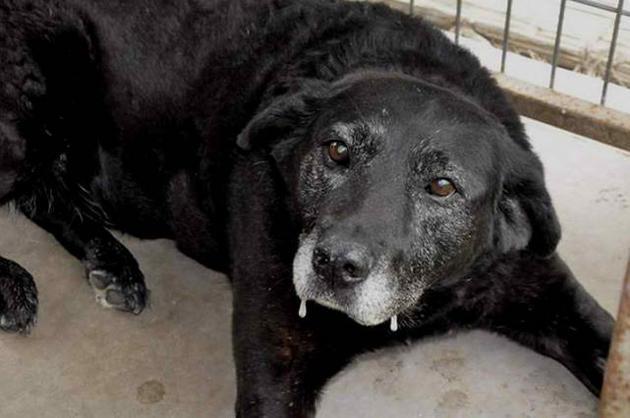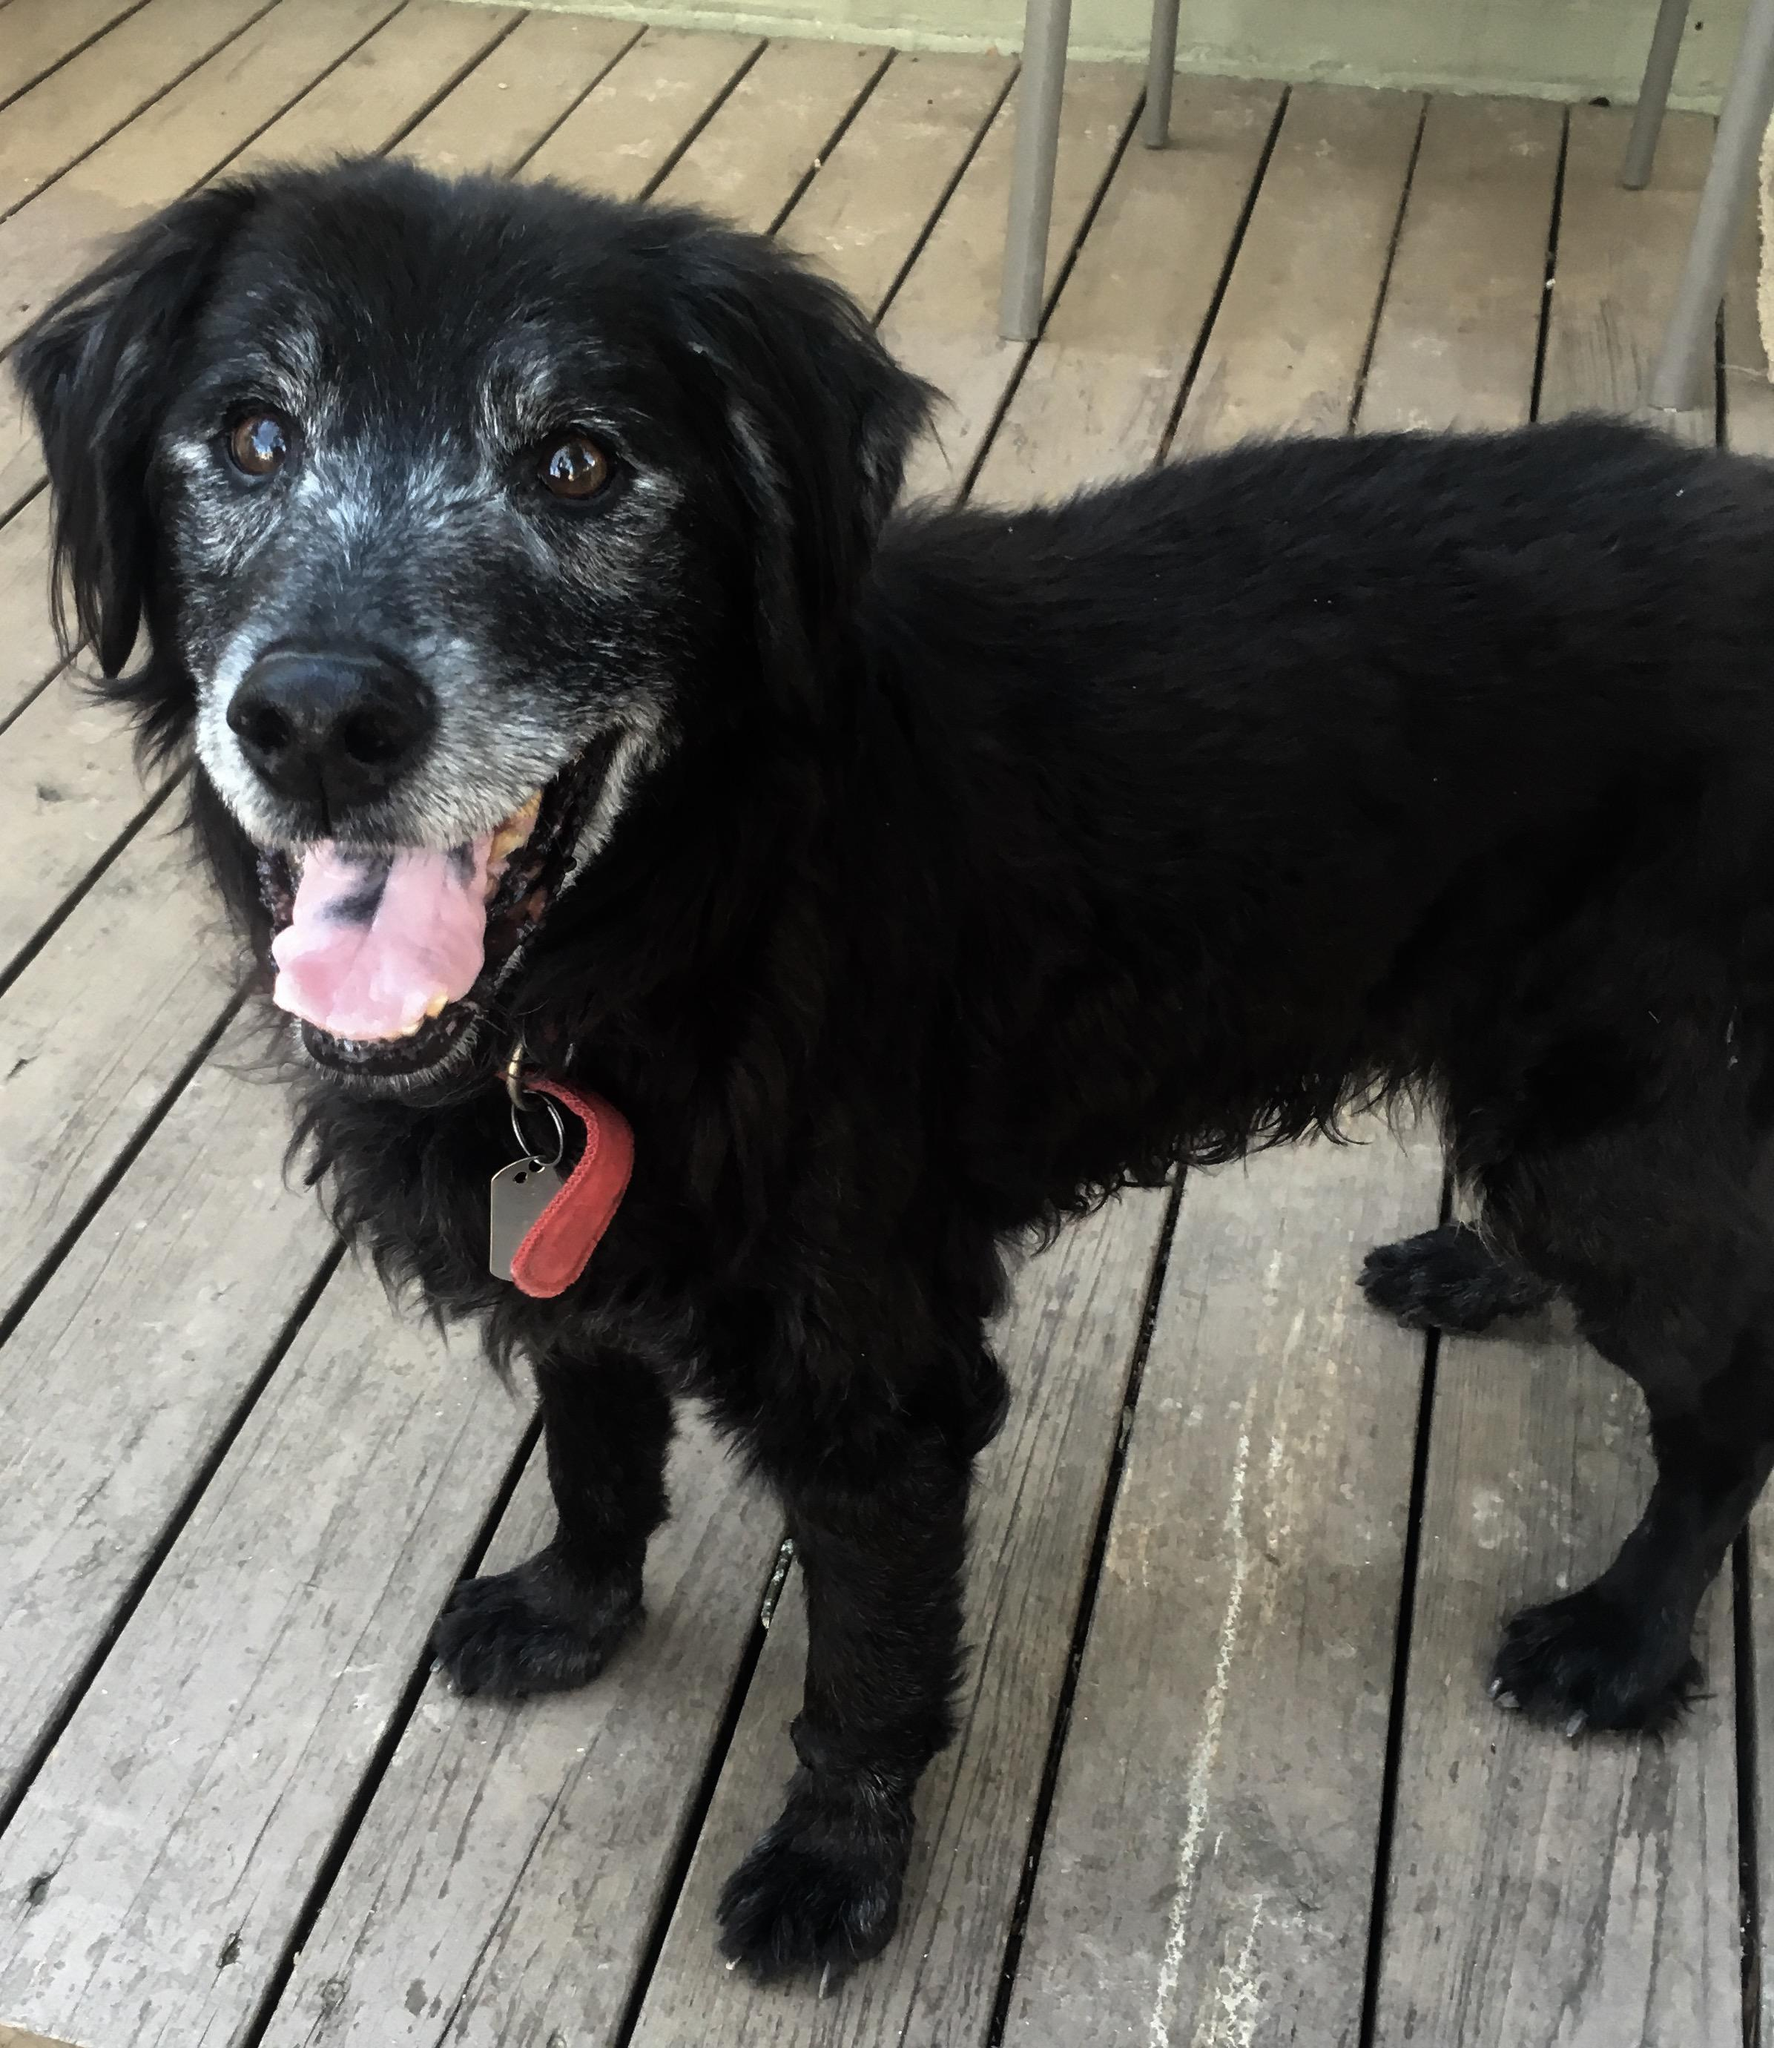The first image is the image on the left, the second image is the image on the right. For the images displayed, is the sentence "One image contains exactly one reclining chocolate-brown dog." factually correct? Answer yes or no. No. The first image is the image on the left, the second image is the image on the right. Examine the images to the left and right. Is the description "There is one black dog that has its mouth open in one of the images." accurate? Answer yes or no. Yes. 